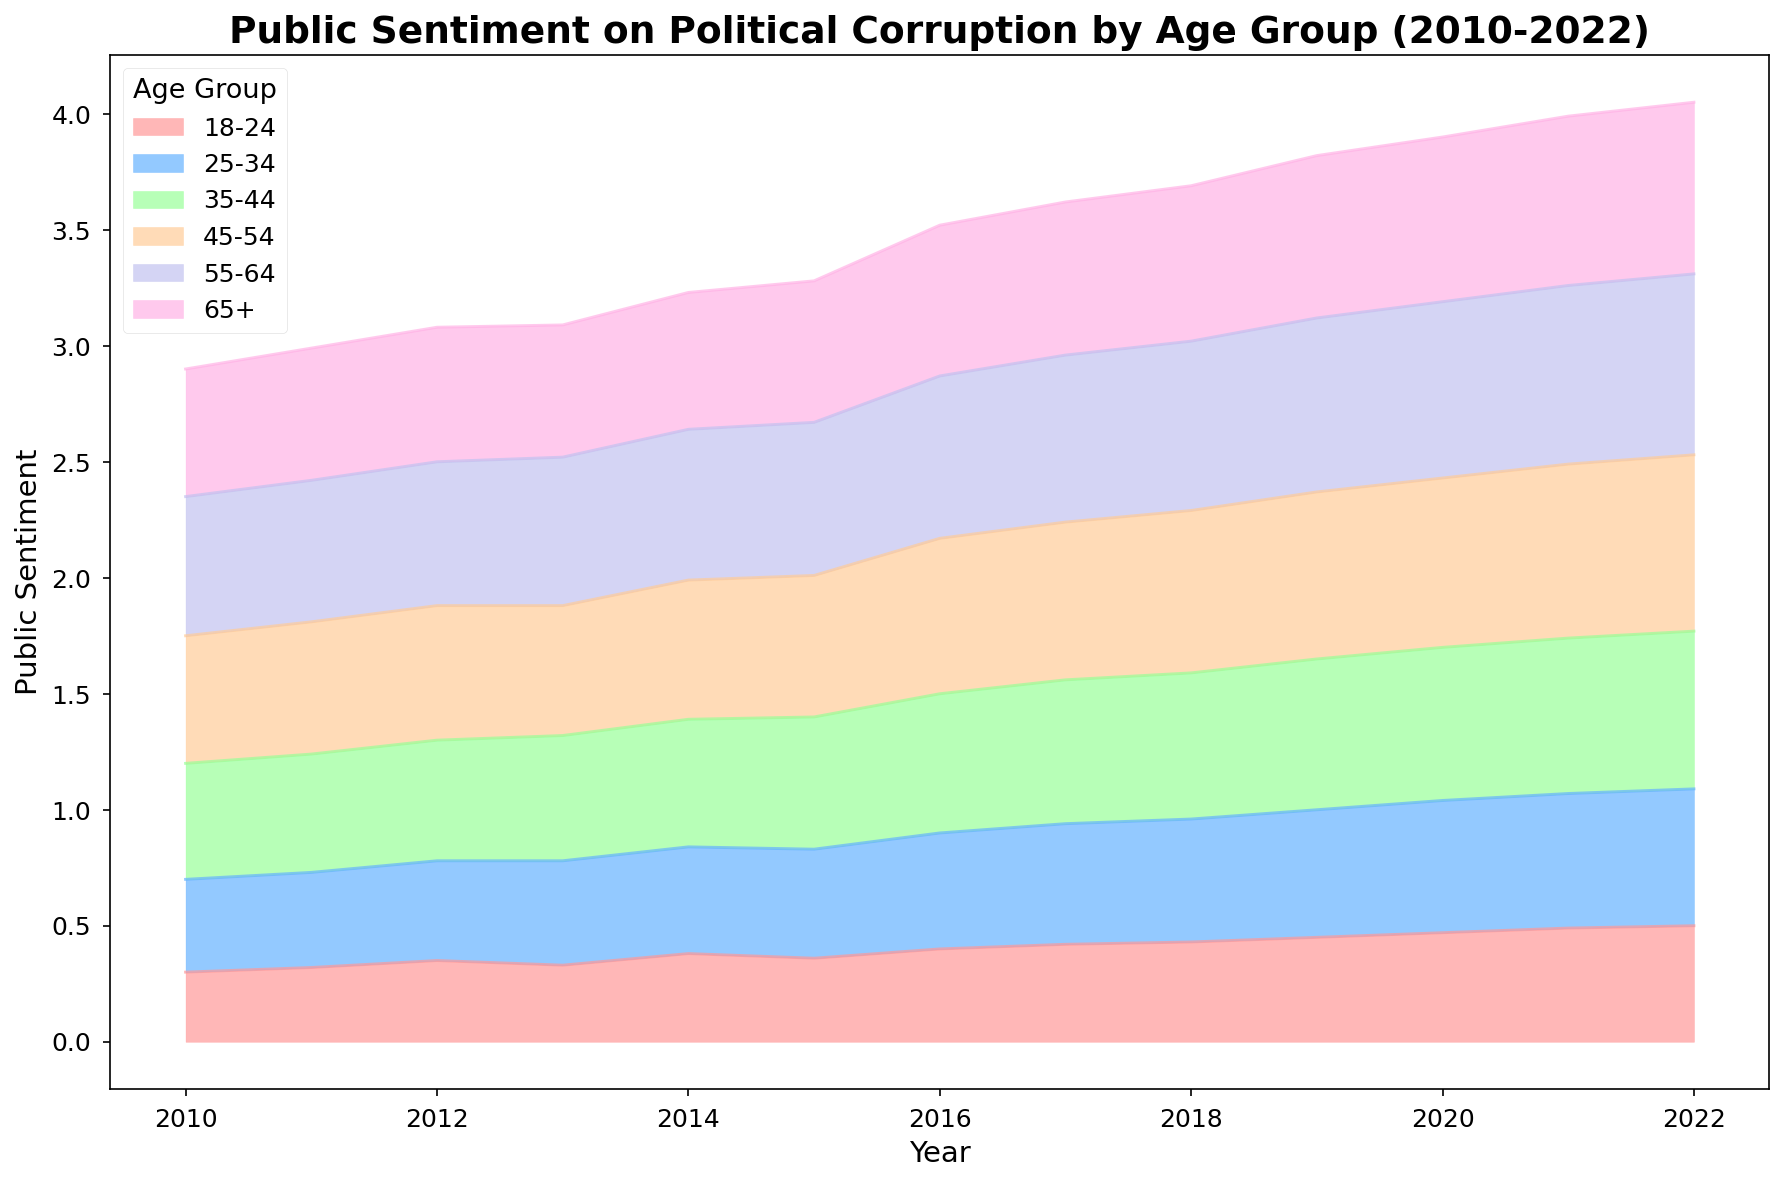Which age group shows the highest level of public sentiment on political corruption in 2022? To answer this, look at the values towards the end of the area chart, specifically for the year 2022, and identify which age group has the highest sentiment value among them.
Answer: 55-64 How does the sentiment of the 18-24 age group in 2010 compare to the sentiment of the 45-54 age group in the same year? Locate the sentiment values for both age groups in the year 2010 in the area chart. Compare the two values directly.
Answer: Lower Between 2013 and 2014, which age group showed the most increase in public sentiment on political corruption? Compare the sentiment values of each age group between the years 2013 and 2014 and identify which one had the largest increase.
Answer: 18-24 Which age group shows the most consistent (least variable) sentiment trend over the years? To determine which group has the most consistent trend, look at the smoothness and stability of each age group's area over the entire chart from 2010 to 2022.
Answer: 65+ Which age group increased their sentiment value by the largest margin between 2016 and 2022? Compare the sentiment values for each age group between the years 2016 and 2022 and find the age group with the largest positive difference.
Answer: 55-64 Which age group had the highest increase in sentiment from the year 2010 to 2022? Calculate the difference in sentiment values for each age group between 2010 and 2022 and identify which age group had the maximum increase.
Answer: 55-64 